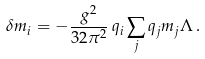Convert formula to latex. <formula><loc_0><loc_0><loc_500><loc_500>\delta m _ { i } = - \frac { g ^ { 2 } } { 3 2 \pi ^ { 2 } } \, q _ { i } \sum _ { j } q _ { j } m _ { j } \Lambda \, .</formula> 